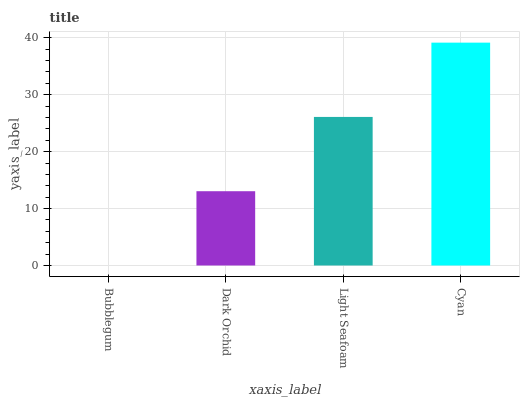Is Bubblegum the minimum?
Answer yes or no. Yes. Is Cyan the maximum?
Answer yes or no. Yes. Is Dark Orchid the minimum?
Answer yes or no. No. Is Dark Orchid the maximum?
Answer yes or no. No. Is Dark Orchid greater than Bubblegum?
Answer yes or no. Yes. Is Bubblegum less than Dark Orchid?
Answer yes or no. Yes. Is Bubblegum greater than Dark Orchid?
Answer yes or no. No. Is Dark Orchid less than Bubblegum?
Answer yes or no. No. Is Light Seafoam the high median?
Answer yes or no. Yes. Is Dark Orchid the low median?
Answer yes or no. Yes. Is Cyan the high median?
Answer yes or no. No. Is Light Seafoam the low median?
Answer yes or no. No. 